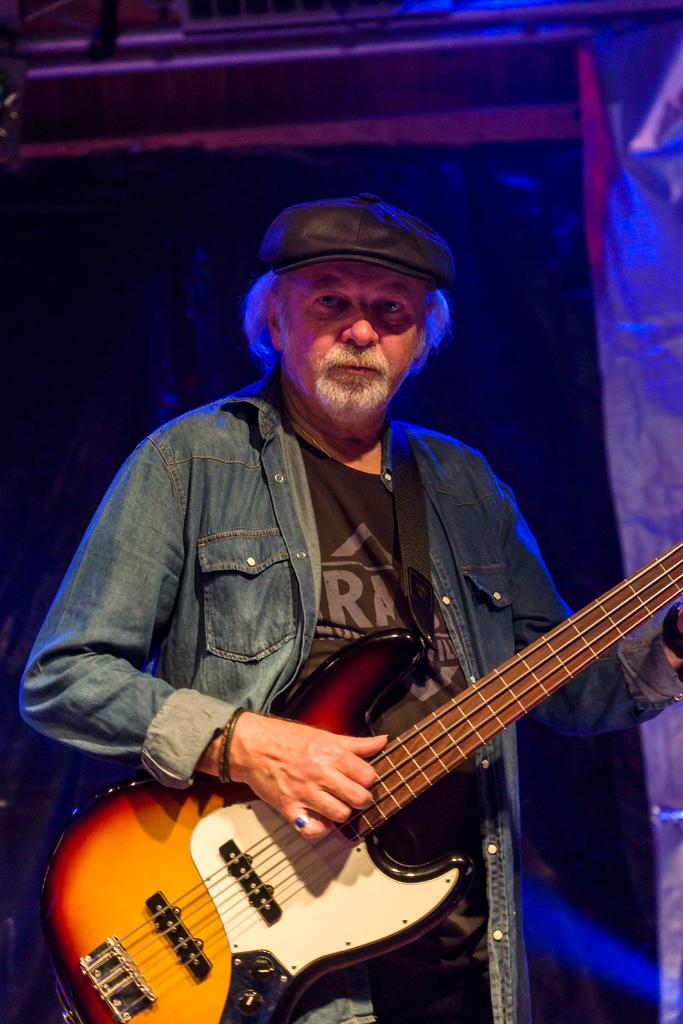What is the main subject of the image? There is a person in the image. What is the person doing in the image? The person is standing and playing a guitar. What clothing items is the person wearing in the image? The person is wearing a jacket and a cap. What shape is the reward given to the person for playing the guitar in the image? There is no reward present in the image, and therefore no shape can be determined. 